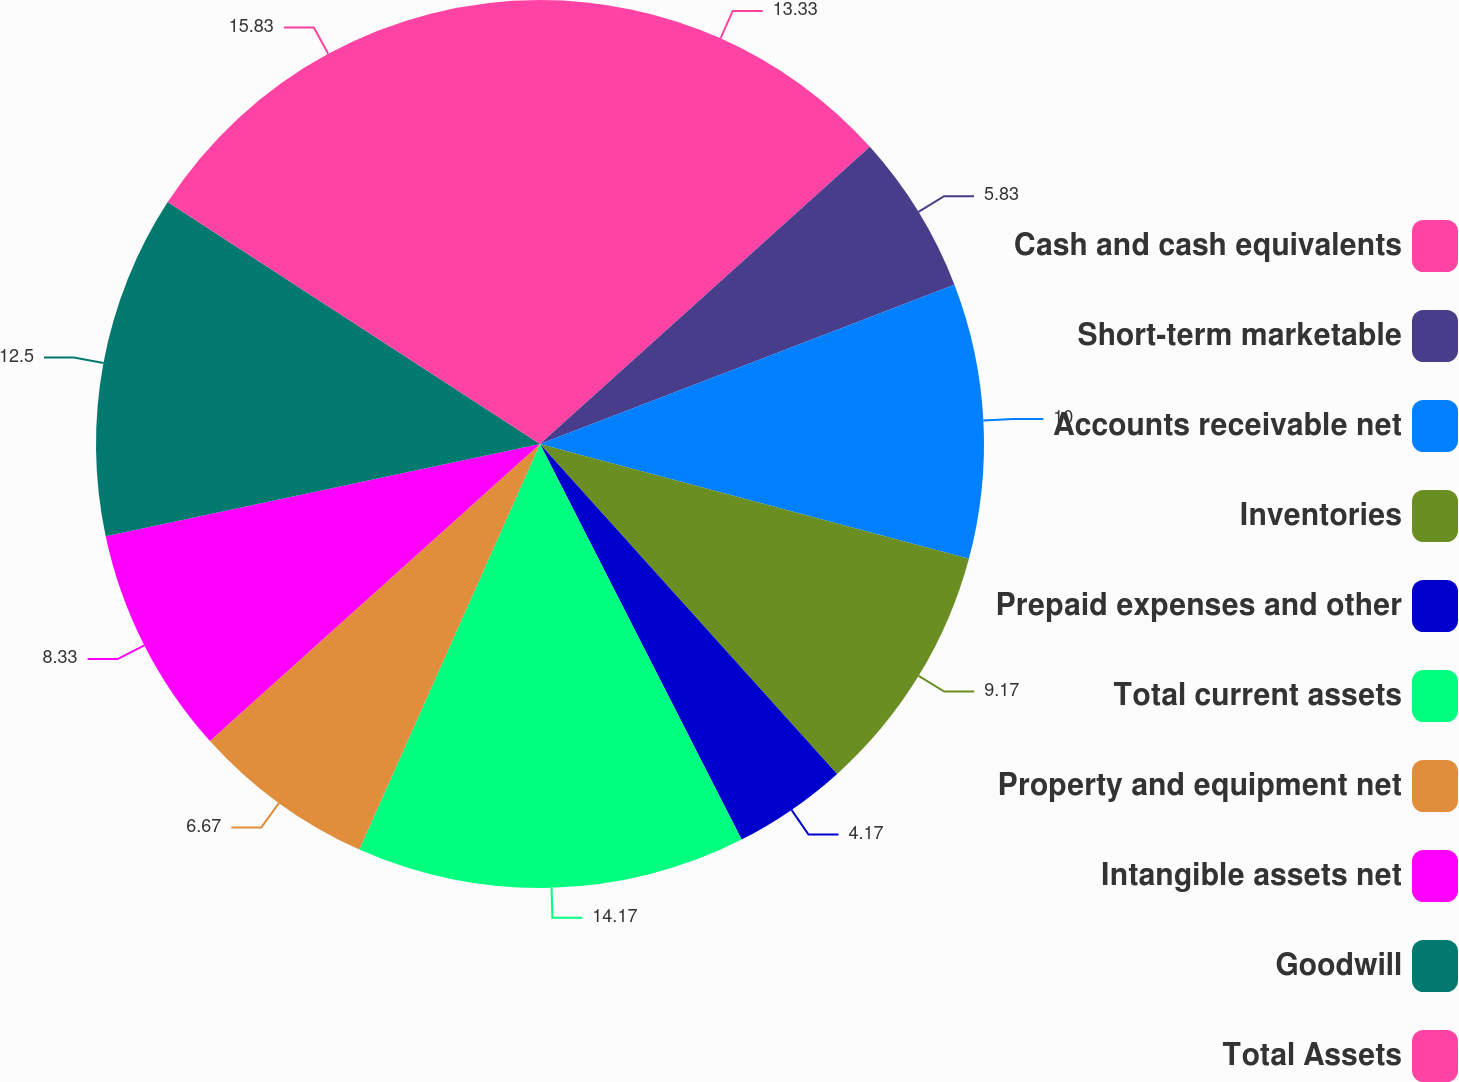<chart> <loc_0><loc_0><loc_500><loc_500><pie_chart><fcel>Cash and cash equivalents<fcel>Short-term marketable<fcel>Accounts receivable net<fcel>Inventories<fcel>Prepaid expenses and other<fcel>Total current assets<fcel>Property and equipment net<fcel>Intangible assets net<fcel>Goodwill<fcel>Total Assets<nl><fcel>13.33%<fcel>5.83%<fcel>10.0%<fcel>9.17%<fcel>4.17%<fcel>14.17%<fcel>6.67%<fcel>8.33%<fcel>12.5%<fcel>15.83%<nl></chart> 